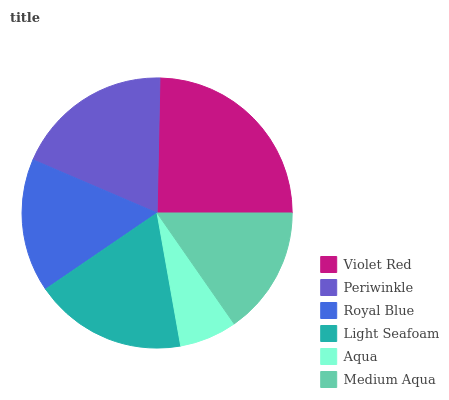Is Aqua the minimum?
Answer yes or no. Yes. Is Violet Red the maximum?
Answer yes or no. Yes. Is Periwinkle the minimum?
Answer yes or no. No. Is Periwinkle the maximum?
Answer yes or no. No. Is Violet Red greater than Periwinkle?
Answer yes or no. Yes. Is Periwinkle less than Violet Red?
Answer yes or no. Yes. Is Periwinkle greater than Violet Red?
Answer yes or no. No. Is Violet Red less than Periwinkle?
Answer yes or no. No. Is Light Seafoam the high median?
Answer yes or no. Yes. Is Royal Blue the low median?
Answer yes or no. Yes. Is Aqua the high median?
Answer yes or no. No. Is Light Seafoam the low median?
Answer yes or no. No. 